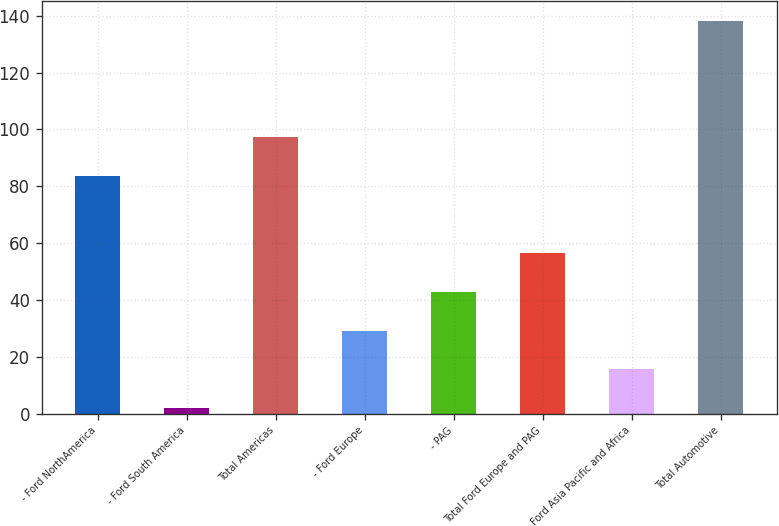Convert chart to OTSL. <chart><loc_0><loc_0><loc_500><loc_500><bar_chart><fcel>- Ford NorthAmerica<fcel>- Ford South America<fcel>Total Americas<fcel>- Ford Europe<fcel>- PAG<fcel>Total Ford Europe and PAG<fcel>Ford Asia Pacific and Africa<fcel>Total Automotive<nl><fcel>83.6<fcel>1.9<fcel>97.24<fcel>29.18<fcel>42.82<fcel>56.46<fcel>15.54<fcel>138.3<nl></chart> 